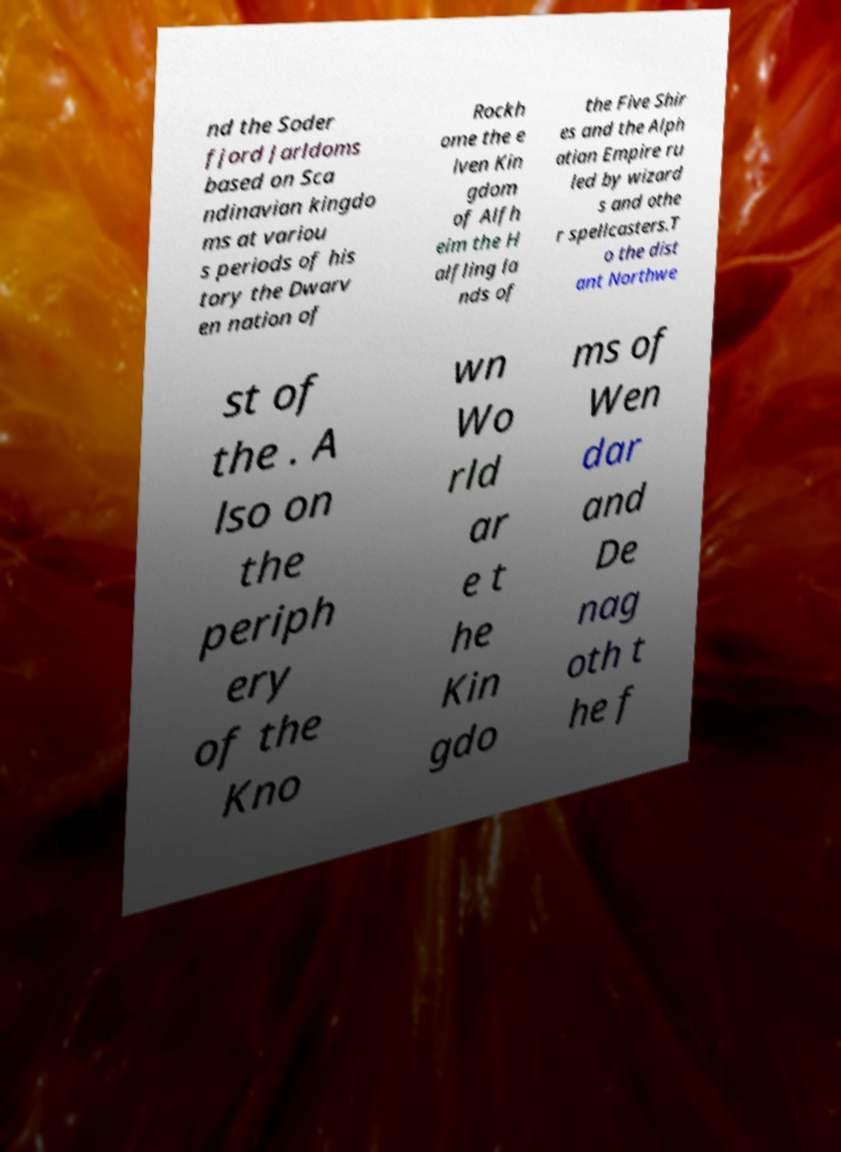For documentation purposes, I need the text within this image transcribed. Could you provide that? nd the Soder fjord Jarldoms based on Sca ndinavian kingdo ms at variou s periods of his tory the Dwarv en nation of Rockh ome the e lven Kin gdom of Alfh eim the H alfling la nds of the Five Shir es and the Alph atian Empire ru led by wizard s and othe r spellcasters.T o the dist ant Northwe st of the . A lso on the periph ery of the Kno wn Wo rld ar e t he Kin gdo ms of Wen dar and De nag oth t he f 